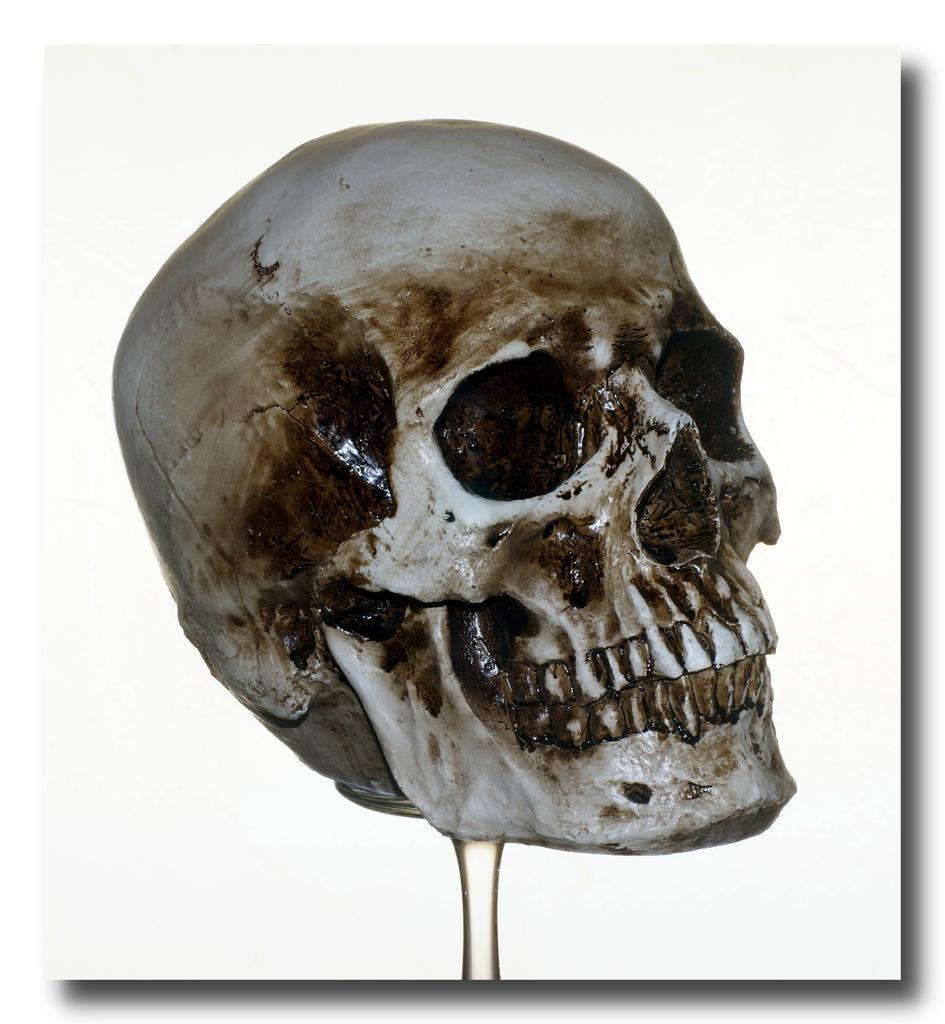What is the main subject of the image? There is a photo of a skull in the image. Is there a veil covering the skull in the image? There is no mention of a veil in the provided facts, and therefore it cannot be determined if a veil is present in the image. 